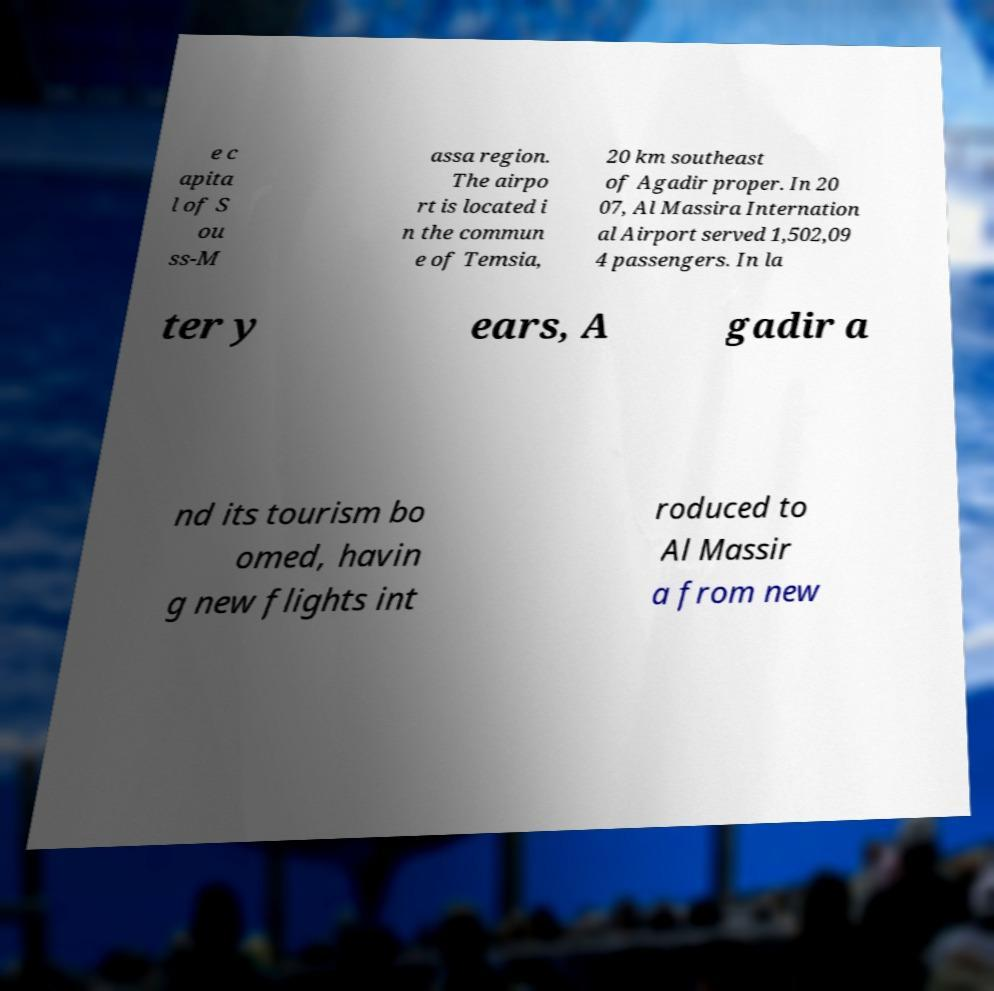Can you accurately transcribe the text from the provided image for me? e c apita l of S ou ss-M assa region. The airpo rt is located i n the commun e of Temsia, 20 km southeast of Agadir proper. In 20 07, Al Massira Internation al Airport served 1,502,09 4 passengers. In la ter y ears, A gadir a nd its tourism bo omed, havin g new flights int roduced to Al Massir a from new 